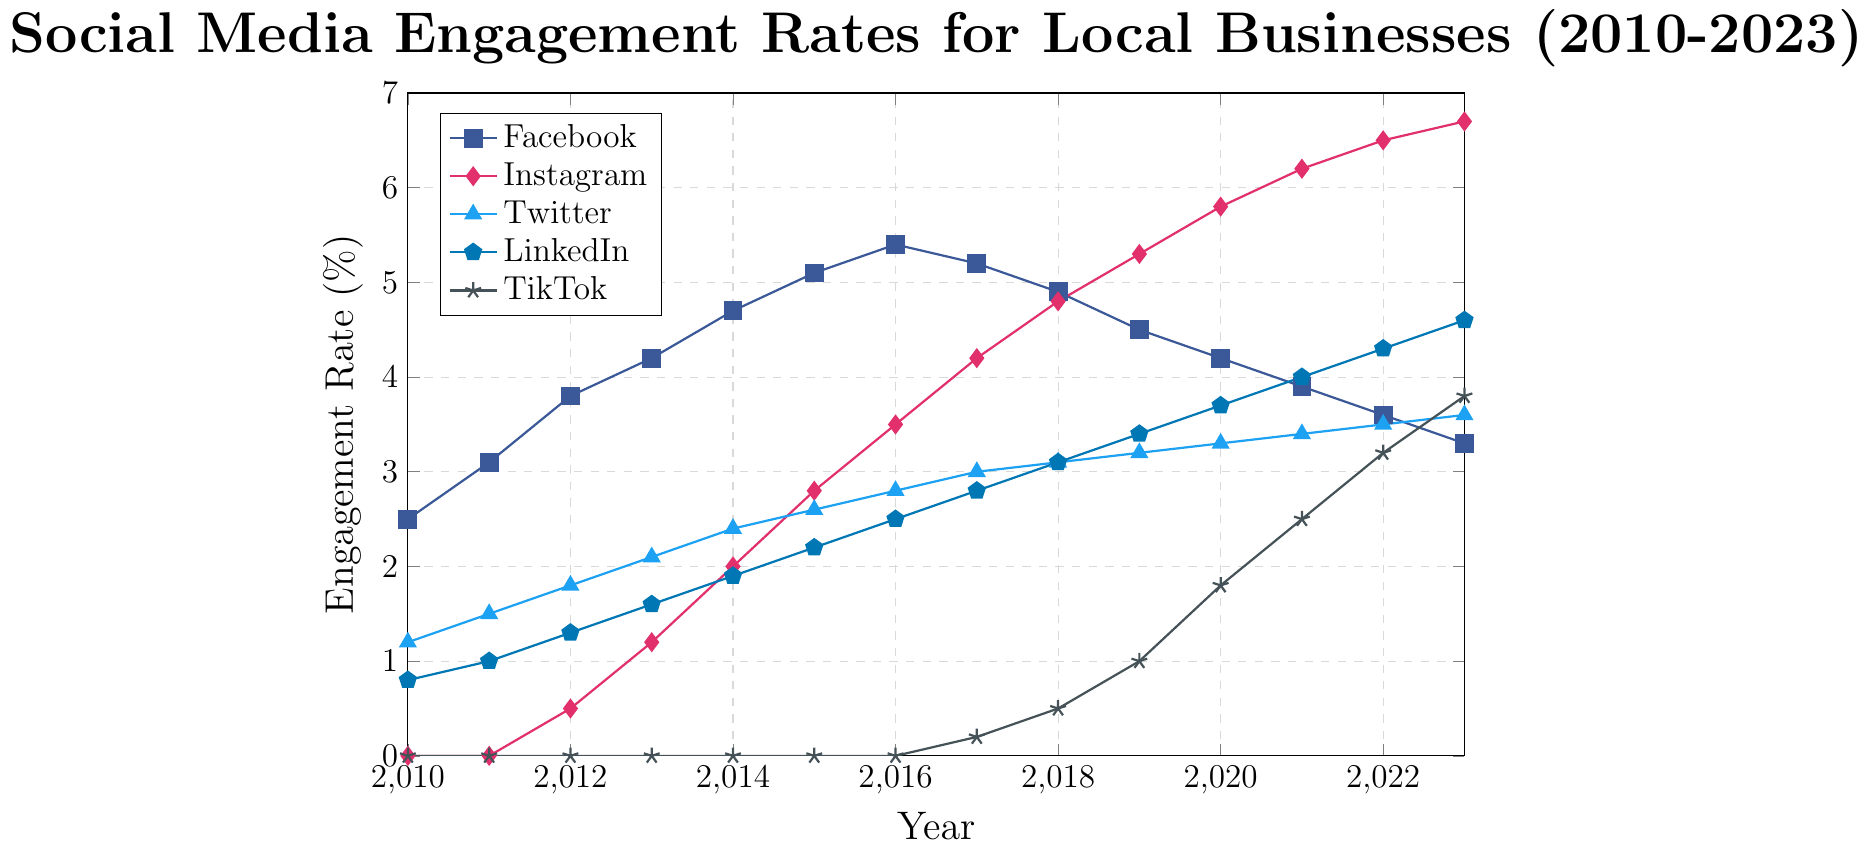What platform had the highest engagement rate in 2023? To find the highest engagement rate in 2023, look at the endpoint of each line on the chart for 2023. The Instagram line reaches the highest point, indicating the highest engagement rate.
Answer: Instagram Which year did TikTok start showing presence in engagement rates? Observe the TikTok line on the chart. It starts to rise from 0 in the year 2017.
Answer: 2017 Which social media platform showed a continual increase in engagement rate from 2010 to 2023? Examine the slope of each line from 2010 to 2023. All lines show a general increase, but Instagram has a steady upward trend without any dips.
Answer: Instagram How did LinkedIn's engagement rate from 2010 compare to 2023? Compare the LinkedIn engagement rate between the years 2010 and 2023. In 2010, it was 0.8%, and in 2023, it is 4.6%.
Answer: 2010: 0.8%, 2023: 4.6% What is the trend for Facebook's engagement rate from 2017 to 2023? Look at the Facebook line between the years 2017 to 2023. It shows a declining trend over this period.
Answer: Declining Which platform had the smallest change in engagement rate from 2010 to 2023? Calculate the difference in engagement rates from 2010 to 2023 for each platform. Twitter has the smallest change, from 1.2% in 2010 to 3.6% in 2023, which is a change of 2.4%.
Answer: Twitter Between 2020 to 2023, which platform showed the largest increase in engagement rate? Check the slopes of all platforms between 2020 and 2023. TikTok's engagement rate increased from 1.8% to 3.8%, which is the largest increase.
Answer: TikTok In 2015, which platform had the second highest engagement rate? Observe the engagement rates for all platforms in 2015. Facebook is the highest at 5.1%, and Instagram is the second highest at 2.8%.
Answer: Instagram What was the general trend for Twitter's engagement rate from 2010 to 2023? Follow the Twitter line from 2010 to 2023. It shows a steady increase over the years.
Answer: Increasing How did the engagement rates for Instagram and TikTok compare in 2019? Compare the points for Instagram and TikTok in 2019. Instagram had a rate of 5.3%, whereas TikTok had 1.0%.
Answer: Instagram: 5.3%, TikTok: 1.0% 